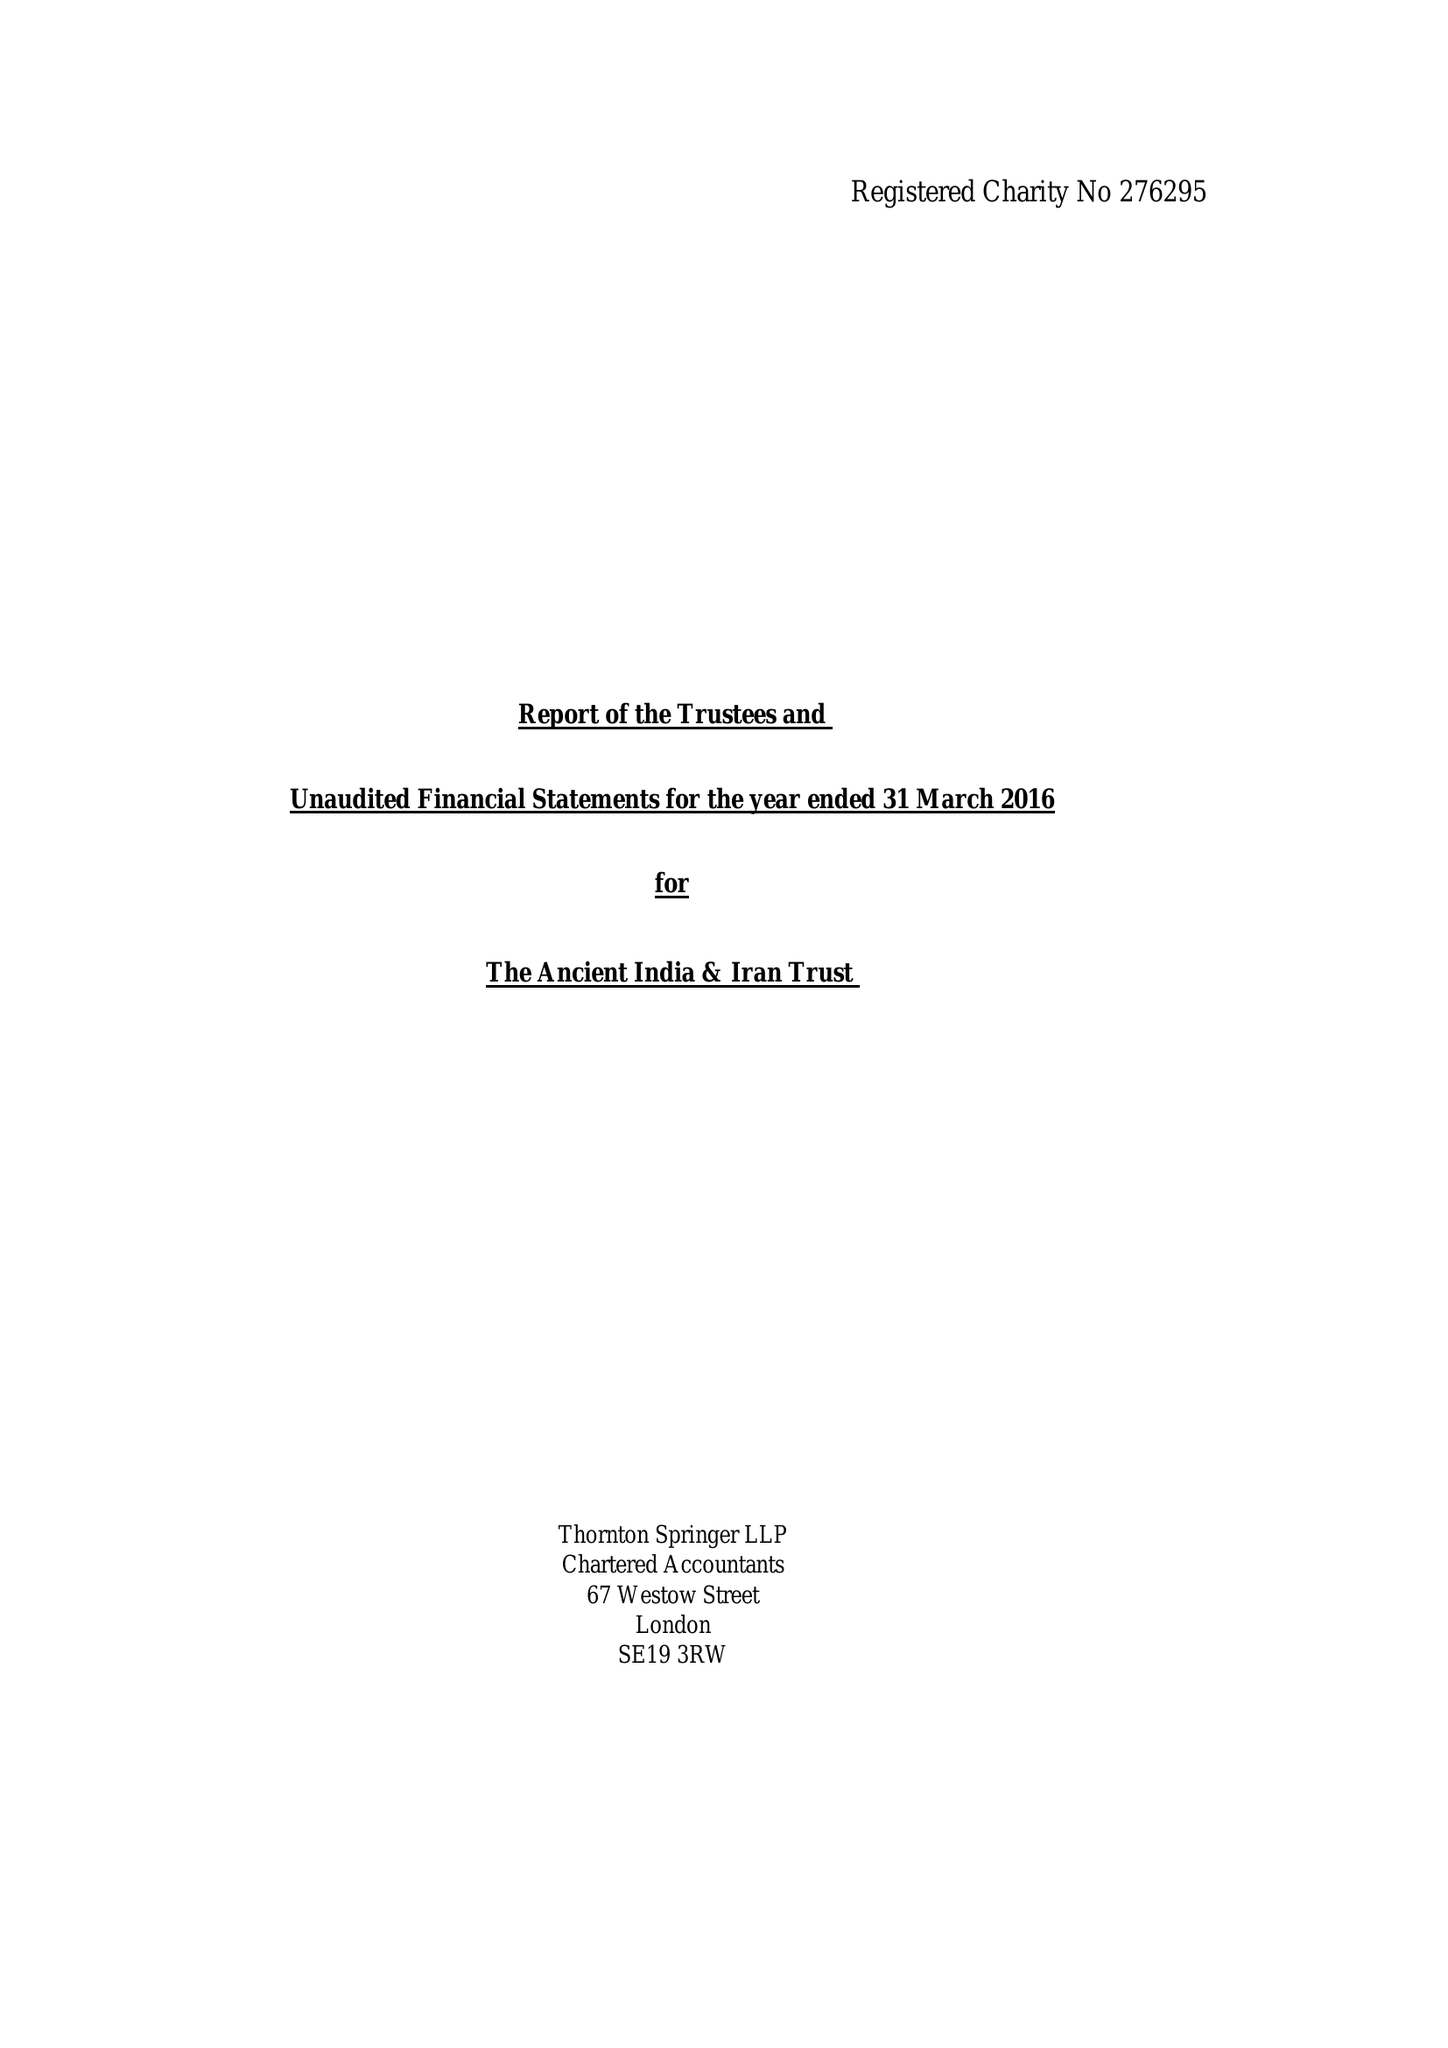What is the value for the charity_number?
Answer the question using a single word or phrase. 276295 